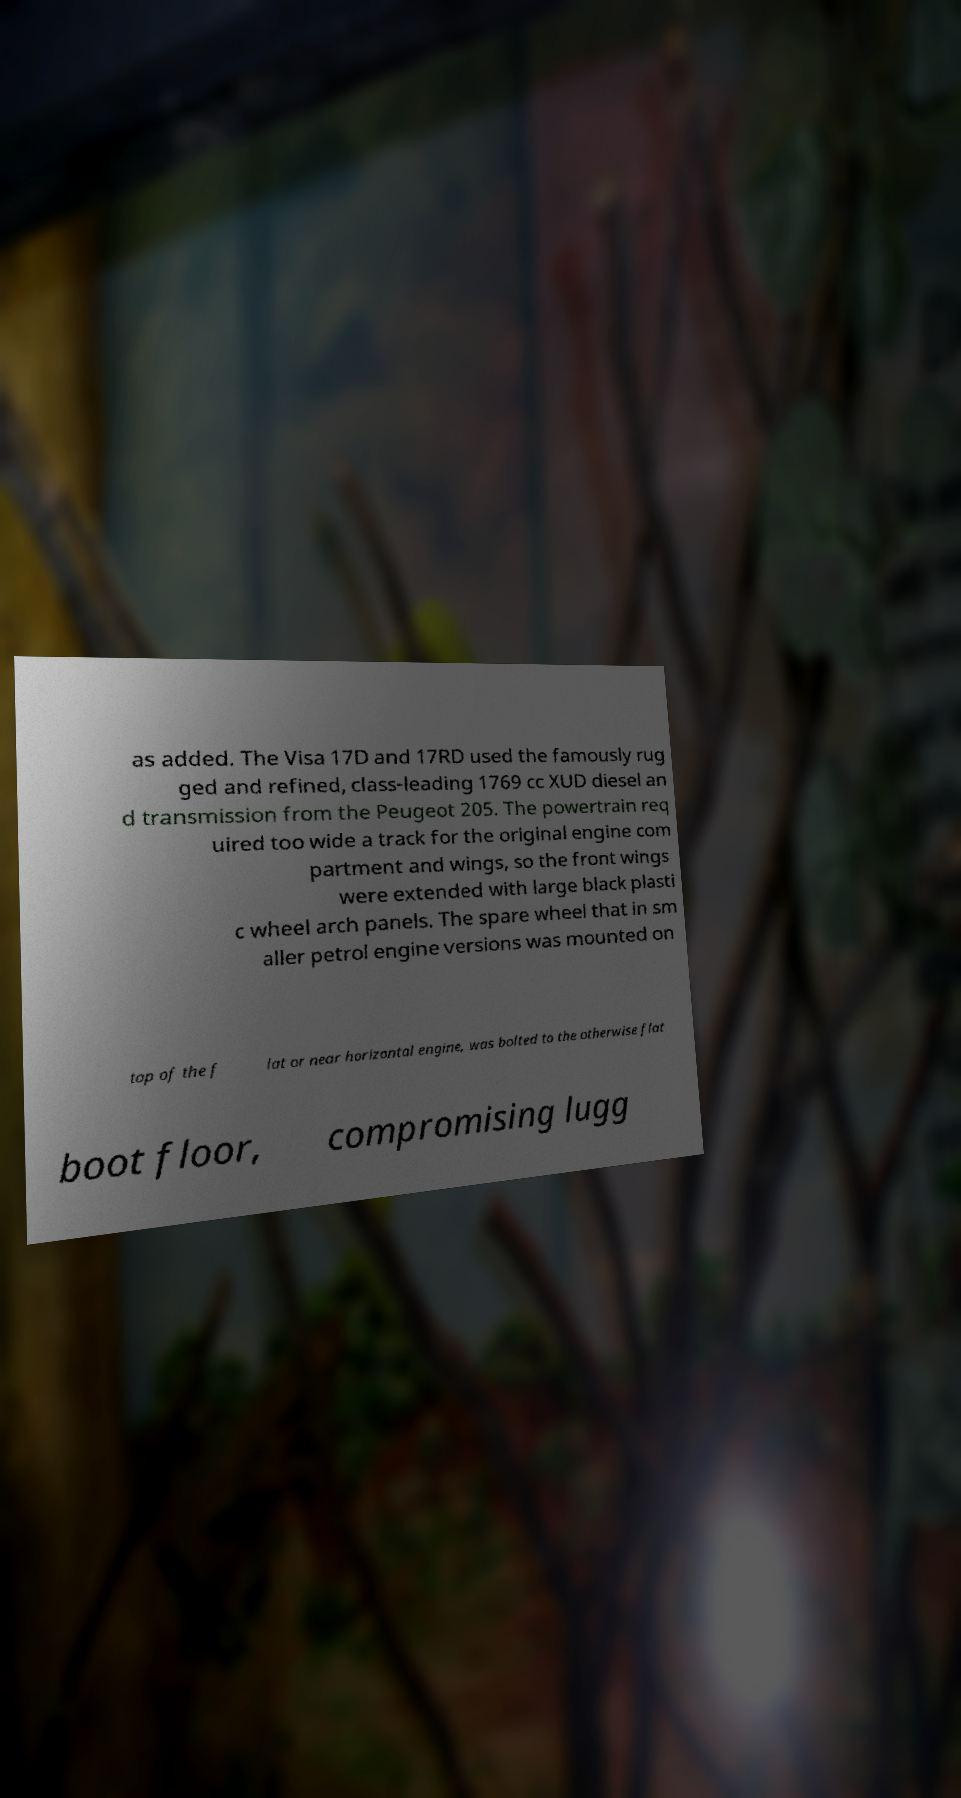What messages or text are displayed in this image? I need them in a readable, typed format. as added. The Visa 17D and 17RD used the famously rug ged and refined, class-leading 1769 cc XUD diesel an d transmission from the Peugeot 205. The powertrain req uired too wide a track for the original engine com partment and wings, so the front wings were extended with large black plasti c wheel arch panels. The spare wheel that in sm aller petrol engine versions was mounted on top of the f lat or near horizontal engine, was bolted to the otherwise flat boot floor, compromising lugg 